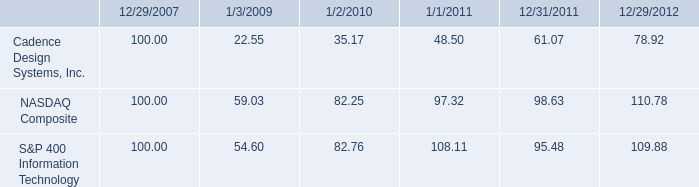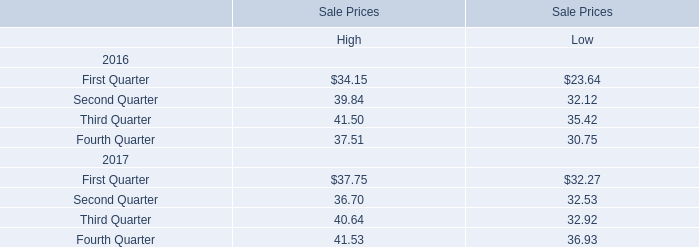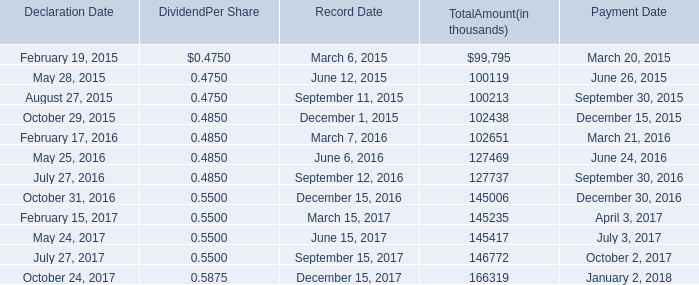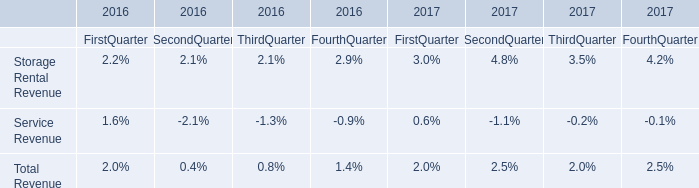Does the average value of First Quarter in 2017 greater than that in 2016? 
Answer: Yes. Which year is the Third Quarter for High the lowest? 
Answer: 2017. 